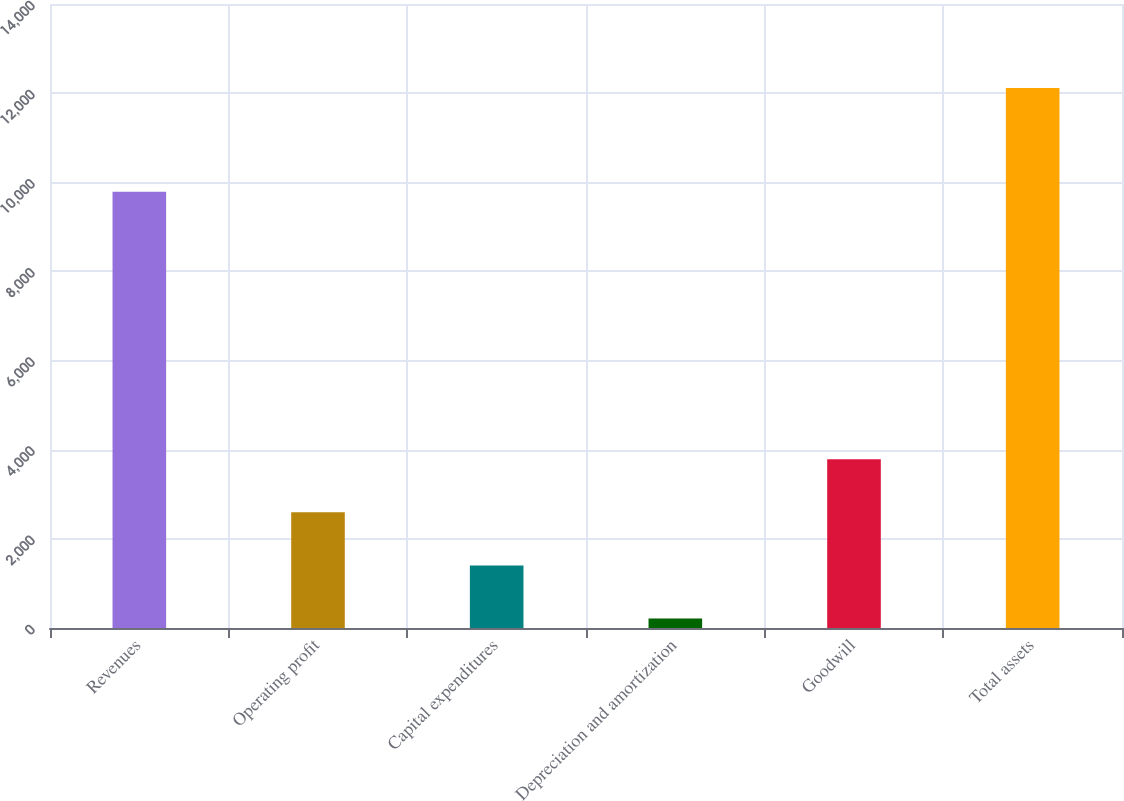<chart> <loc_0><loc_0><loc_500><loc_500><bar_chart><fcel>Revenues<fcel>Operating profit<fcel>Capital expenditures<fcel>Depreciation and amortization<fcel>Goodwill<fcel>Total assets<nl><fcel>9789<fcel>2594.26<fcel>1404.18<fcel>214.1<fcel>3784.34<fcel>12114.9<nl></chart> 